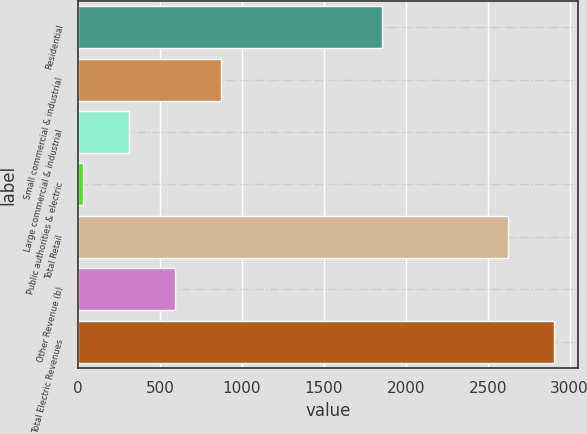Convert chart to OTSL. <chart><loc_0><loc_0><loc_500><loc_500><bar_chart><fcel>Residential<fcel>Small commercial & industrial<fcel>Large commercial & industrial<fcel>Public authorities & electric<fcel>Total Retail<fcel>Other Revenue (b)<fcel>Total Electric Revenues<nl><fcel>1857<fcel>870.3<fcel>310.1<fcel>30<fcel>2627<fcel>590.2<fcel>2907.1<nl></chart> 